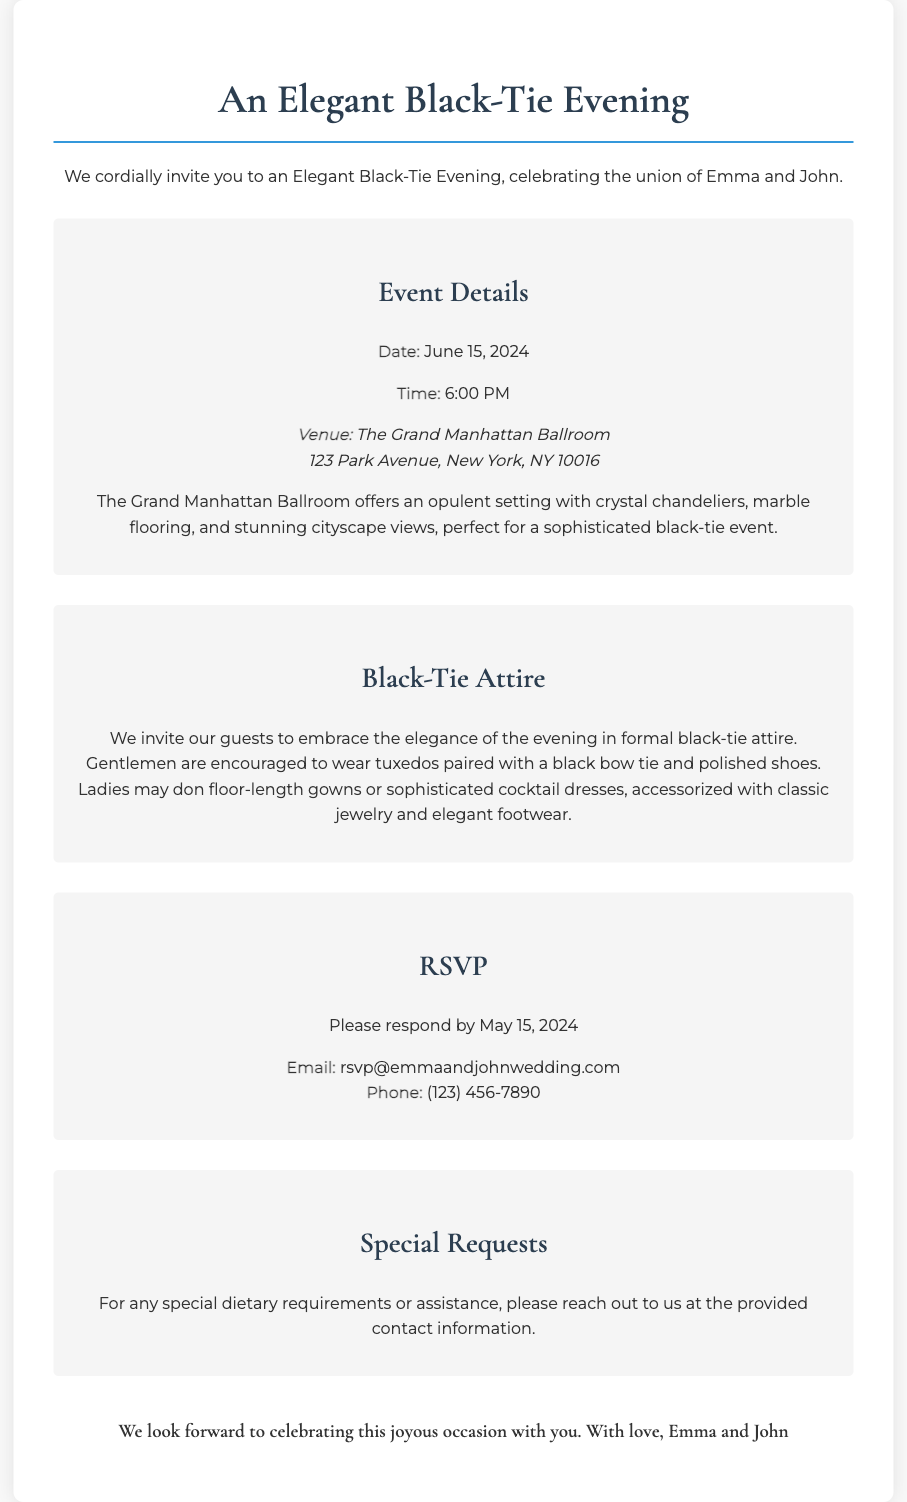What is the date of the wedding? The date of the wedding is explicitly mentioned in the event details section of the document.
Answer: June 15, 2024 What time does the wedding start? The start time for the wedding is provided in the event details area.
Answer: 6:00 PM Where is the venue located? The specific address of the venue can be found under the venue section.
Answer: 123 Park Avenue, New York, NY 10016 What type of attire is requested for the event? The dress code section clearly states the type of attire expected from guests.
Answer: Black-Tie Attire What should gentlemen wear to the wedding? This information is found in the dress code section describing attire for men.
Answer: Tuxedos with a black bow tie What is the email for RSVP? The RSVP section includes the email address for guests to respond to the invitation.
Answer: rsvp@emmaandjohnwedding.com When is the RSVP deadline? The RSVP deadline is mentioned directly in the RSVP section.
Answer: May 15, 2024 What kind of setting does the venue offer? The text describing the venue gives an overview of its features and ambiance.
Answer: Opulent setting with crystal chandeliers How should ladies dress for the event? The dress code section specifies the attire for women attending the wedding.
Answer: Floor-length gowns or sophisticated cocktail dresses What should guests do for special dietary requirements? The special requests section provides guidance on how to address dietary needs.
Answer: Reach out to the contact information provided 